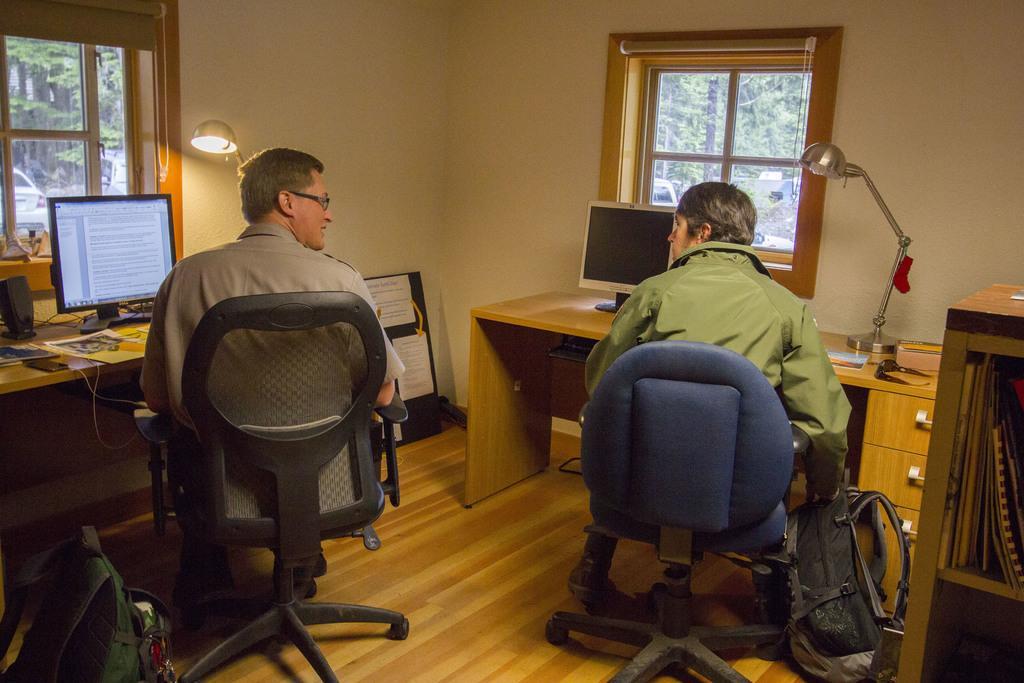Can you describe this image briefly? This picture describes about two people they are seated on the chair in front of them we can see monitors and lights. The right side person is holding a bag in his hands, in the background we can see couple of trees and couple of vehicles. 